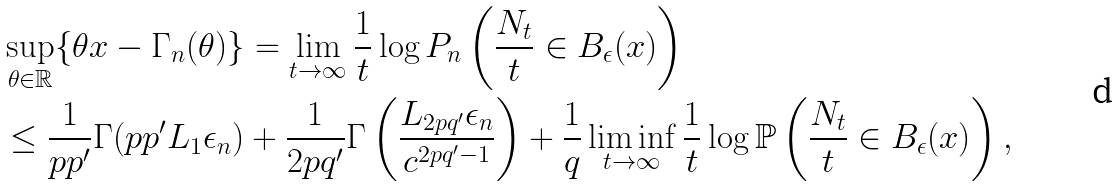Convert formula to latex. <formula><loc_0><loc_0><loc_500><loc_500>& \sup _ { \theta \in \mathbb { R } } \{ \theta x - \Gamma _ { n } ( \theta ) \} = \lim _ { t \rightarrow \infty } \frac { 1 } { t } \log P _ { n } \left ( \frac { N _ { t } } { t } \in B _ { \epsilon } ( x ) \right ) \\ & \leq \frac { 1 } { p p ^ { \prime } } \Gamma ( p p ^ { \prime } L _ { 1 } \epsilon _ { n } ) + \frac { 1 } { 2 p q ^ { \prime } } \Gamma \left ( \frac { L _ { 2 p q ^ { \prime } } \epsilon _ { n } } { c ^ { 2 p q ^ { \prime } - 1 } } \right ) + \frac { 1 } { q } \liminf _ { t \rightarrow \infty } \frac { 1 } { t } \log \mathbb { P } \left ( \frac { N _ { t } } { t } \in B _ { \epsilon } ( x ) \right ) ,</formula> 